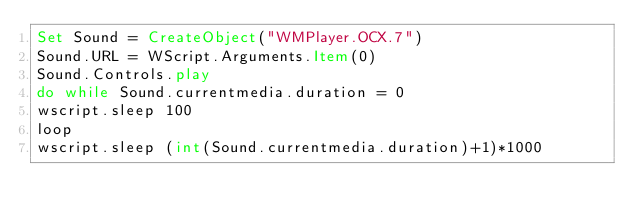Convert code to text. <code><loc_0><loc_0><loc_500><loc_500><_VisualBasic_>Set Sound = CreateObject("WMPlayer.OCX.7")
Sound.URL = WScript.Arguments.Item(0)
Sound.Controls.play
do while Sound.currentmedia.duration = 0
wscript.sleep 100
loop
wscript.sleep (int(Sound.currentmedia.duration)+1)*1000
</code> 